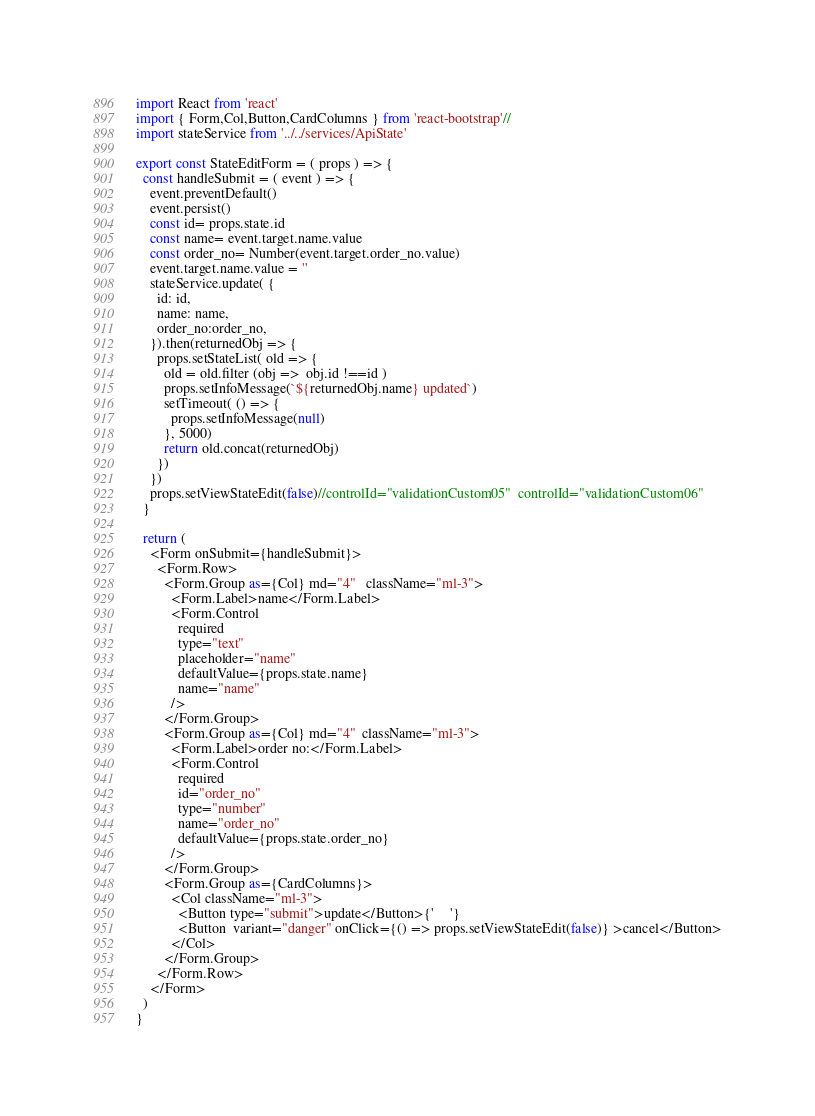Convert code to text. <code><loc_0><loc_0><loc_500><loc_500><_JavaScript_>

import React from 'react'
import { Form,Col,Button,CardColumns } from 'react-bootstrap'//
import stateService from '../../services/ApiState'

export const StateEditForm = ( props ) => {
  const handleSubmit = ( event ) => {
    event.preventDefault()
    event.persist()
    const id= props.state.id
    const name= event.target.name.value
    const order_no= Number(event.target.order_no.value)
    event.target.name.value = ''
    stateService.update( {
      id: id,
      name: name,
      order_no:order_no,
    }).then(returnedObj => {
      props.setStateList( old => {
        old = old.filter (obj =>  obj.id !==id )
        props.setInfoMessage(`${returnedObj.name} updated`)
        setTimeout( () => {
          props.setInfoMessage(null)
        }, 5000)
        return old.concat(returnedObj)
      })
    })
    props.setViewStateEdit(false)//controlId="validationCustom05"  controlId="validationCustom06"
  }

  return (
    <Form onSubmit={handleSubmit}>
      <Form.Row>
        <Form.Group as={Col} md="4"   className="ml-3">
          <Form.Label>name</Form.Label>
          <Form.Control
            required
            type="text"
            placeholder="name"
            defaultValue={props.state.name}
            name="name"
          />
        </Form.Group>
        <Form.Group as={Col} md="4"  className="ml-3">
          <Form.Label>order no:</Form.Label>
          <Form.Control
            required
            id="order_no"
            type="number"
            name="order_no"
            defaultValue={props.state.order_no}
          />
        </Form.Group>
        <Form.Group as={CardColumns}>
          <Col className="ml-3">
            <Button type="submit">update</Button>{'    '}
            <Button  variant="danger" onClick={() => props.setViewStateEdit(false)} >cancel</Button>
          </Col>
        </Form.Group>
      </Form.Row>
    </Form>
  )
}</code> 